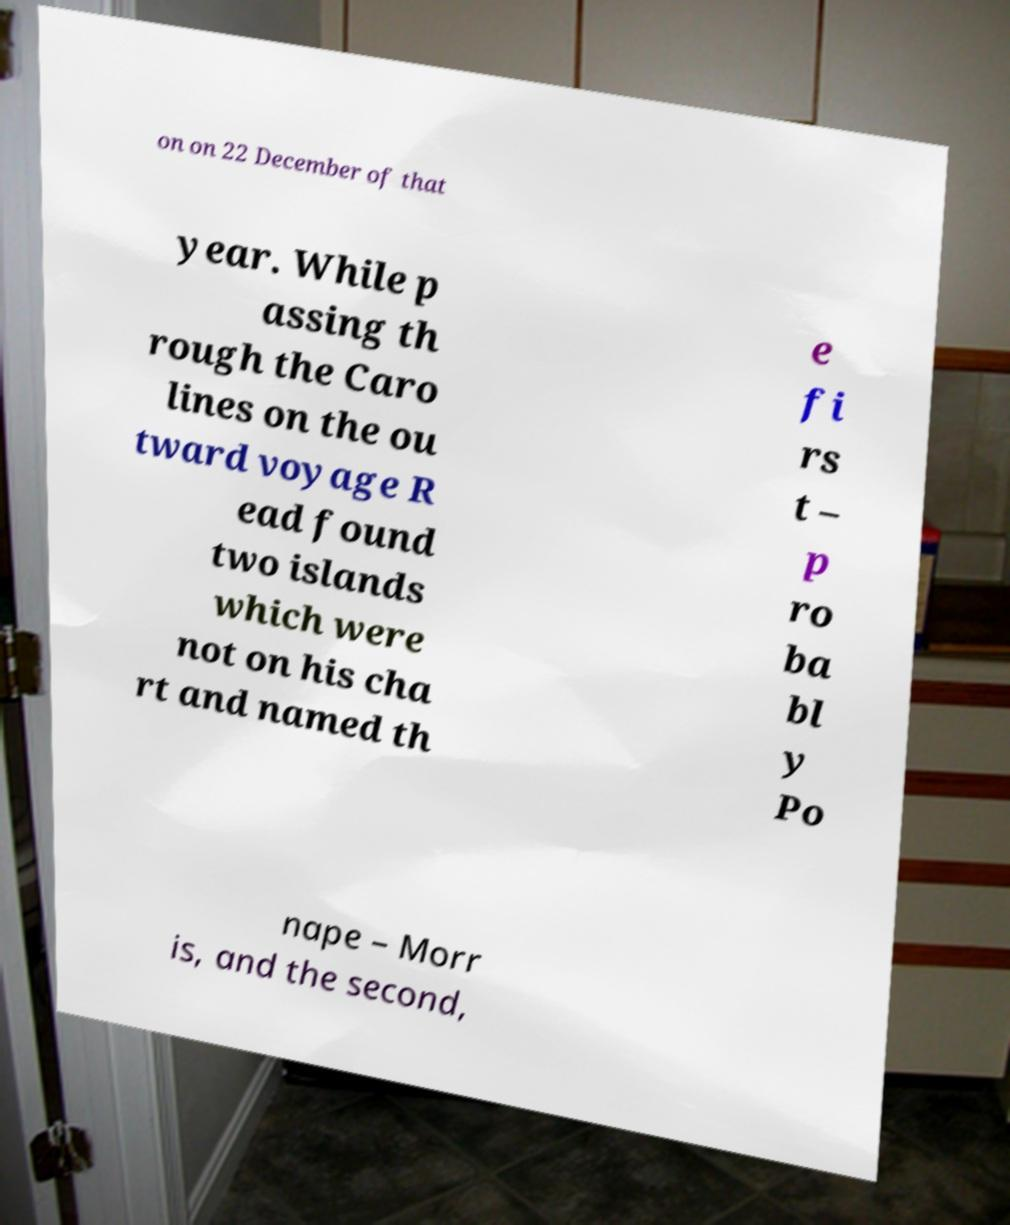Could you assist in decoding the text presented in this image and type it out clearly? on on 22 December of that year. While p assing th rough the Caro lines on the ou tward voyage R ead found two islands which were not on his cha rt and named th e fi rs t – p ro ba bl y Po nape – Morr is, and the second, 